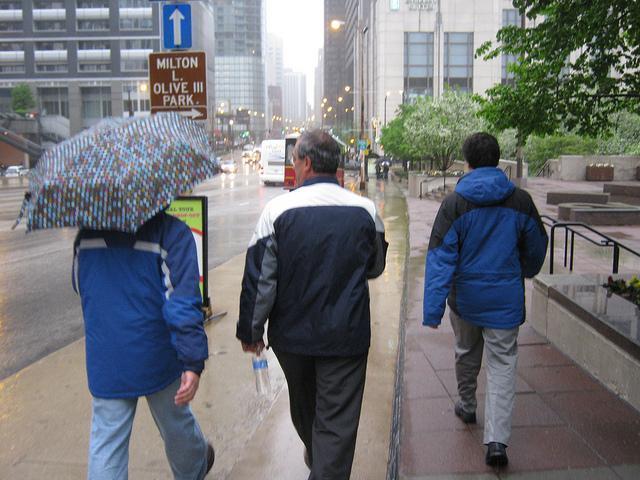What type of area is shown?
Choose the right answer and clarify with the format: 'Answer: answer
Rationale: rationale.'
Options: Forest, urban, coastal, rural. Answer: urban.
Rationale: The tall buildings and street lights gives it away to where they are. 